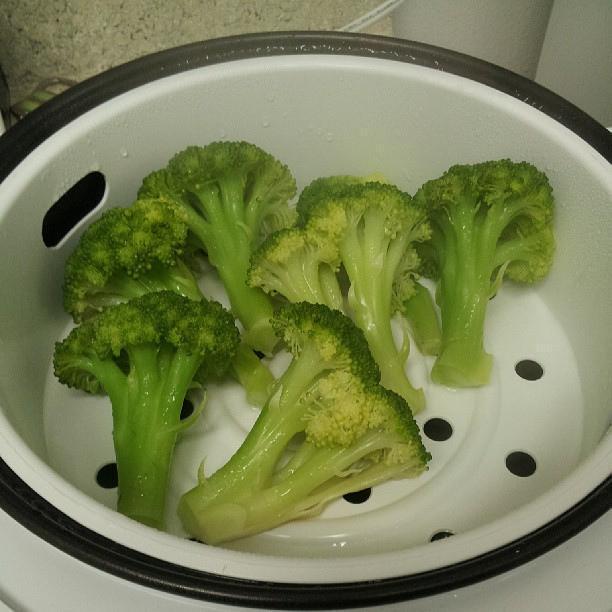How many pieces of broccoli are there?
Give a very brief answer. 6. How many broccolis are there?
Give a very brief answer. 2. How many people are drinking from their cup?
Give a very brief answer. 0. 